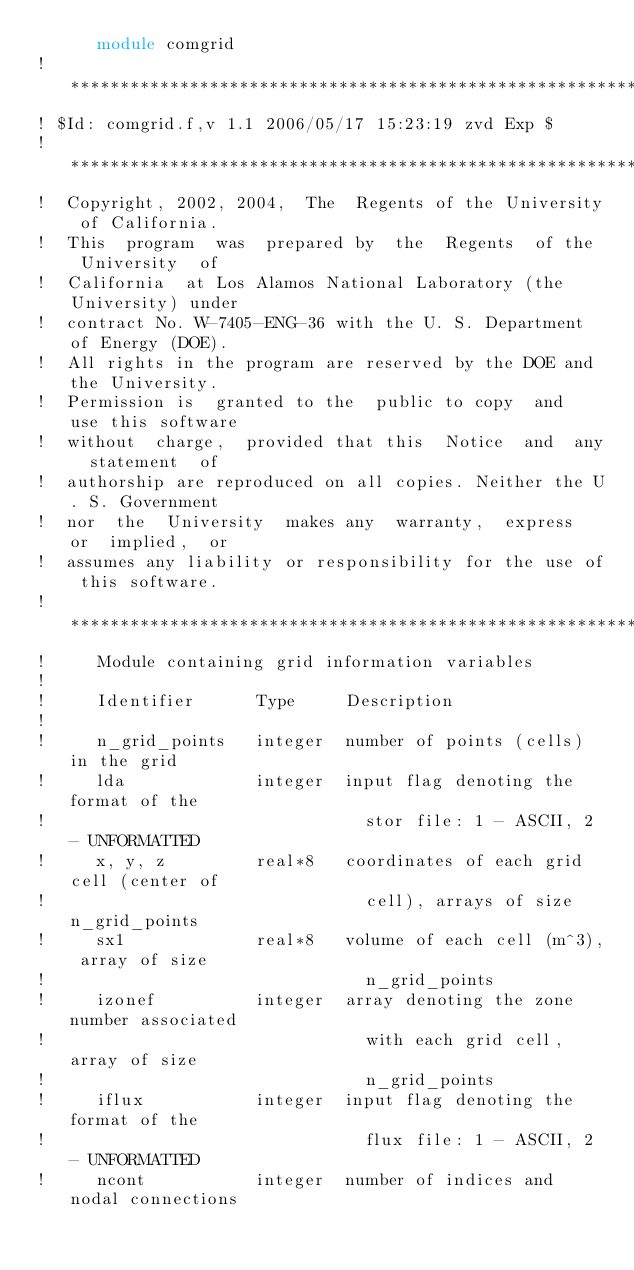Convert code to text. <code><loc_0><loc_0><loc_500><loc_500><_FORTRAN_>      module comgrid
!***********************************************************************
! $Id: comgrid.f,v 1.1 2006/05/17 15:23:19 zvd Exp $
!***********************************************************************
!  Copyright, 2002, 2004,  The  Regents of the University of California.
!  This  program  was  prepared by  the  Regents  of the  University  of
!  California  at Los Alamos National Laboratory (the  University) under
!  contract No. W-7405-ENG-36 with the U. S. Department of Energy (DOE).
!  All rights in the program are reserved by the DOE and the University.
!  Permission is  granted to the  public to copy  and  use this software
!  without  charge,  provided that this  Notice  and  any  statement  of
!  authorship are reproduced on all copies. Neither the U. S. Government
!  nor  the  University  makes any  warranty,  express  or  implied,  or
!  assumes any liability or responsibility for the use of this software.
!***********************************************************************
!     Module containing grid information variables
!
!     Identifier      Type     Description
!
!     n_grid_points   integer  number of points (cells) in the grid
!     lda             integer  input flag denoting the format of the 
!                                stor file: 1 - ASCII, 2 - UNFORMATTED
!     x, y, z         real*8   coordinates of each grid cell (center of
!                                cell), arrays of size n_grid_points
!     sx1             real*8   volume of each cell (m^3), array of size 
!                                n_grid_points
!     izonef          integer  array denoting the zone number associated
!                                with each grid cell, array of size 
!                                n_grid_points
!     iflux           integer  input flag denoting the format of the 
!                                flux file: 1 - ASCII, 2 - UNFORMATTED
!     ncont           integer  number of indices and nodal connections </code> 